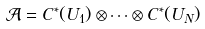Convert formula to latex. <formula><loc_0><loc_0><loc_500><loc_500>\mathcal { A } = C ^ { * } ( U _ { 1 } ) \otimes \cdots \otimes C ^ { * } ( U _ { N } )</formula> 